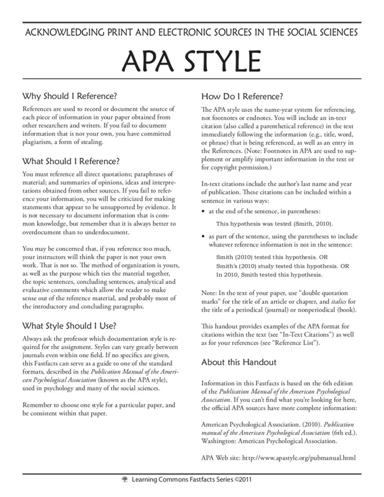What does the image suggest about the formatting of reference lists in APA style? According to the image, the reference list in APA style should be formatted with a hanging indent, where the first line starts at the margin, and subsequent lines are indented. The sources are listed alphabetically by the author's last name and must be double-spaced. 